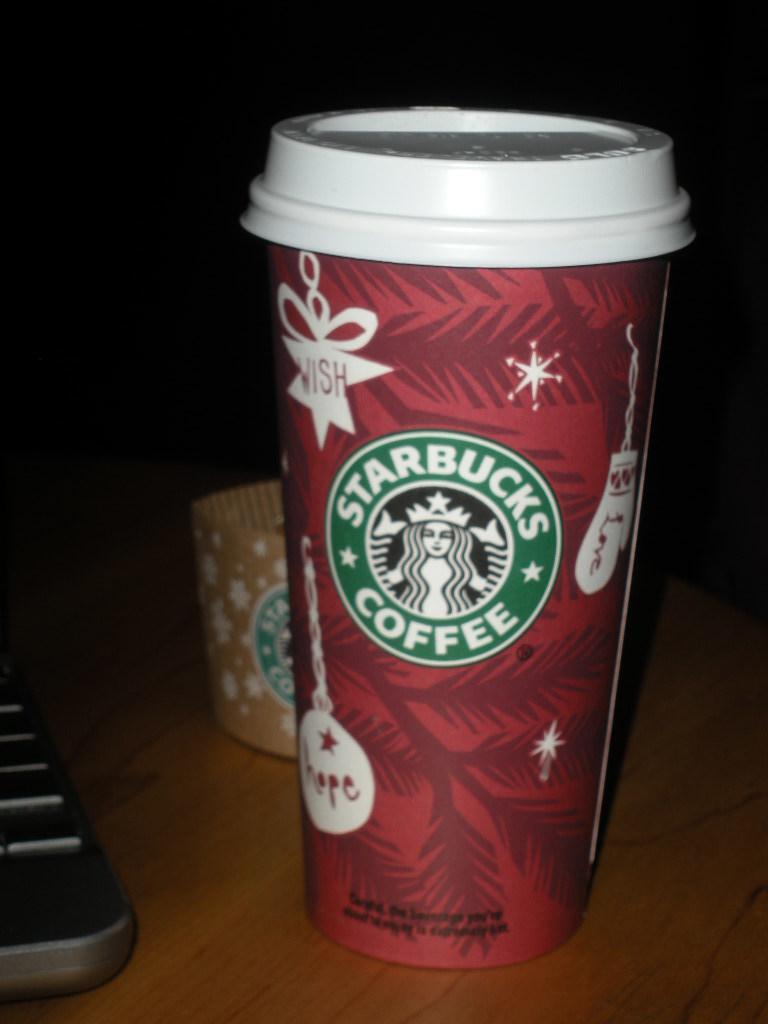What object is visible on the table in the image? There is a cup on the table in the image. Where is the cup located in relation to the table? The cup is on the table in the image. What can be observed about the background of the image? The background of the image is dark. Can you see the father walking down the alley in the image? There is no father or alley present in the image; it only features a cup on a table with a dark background. 